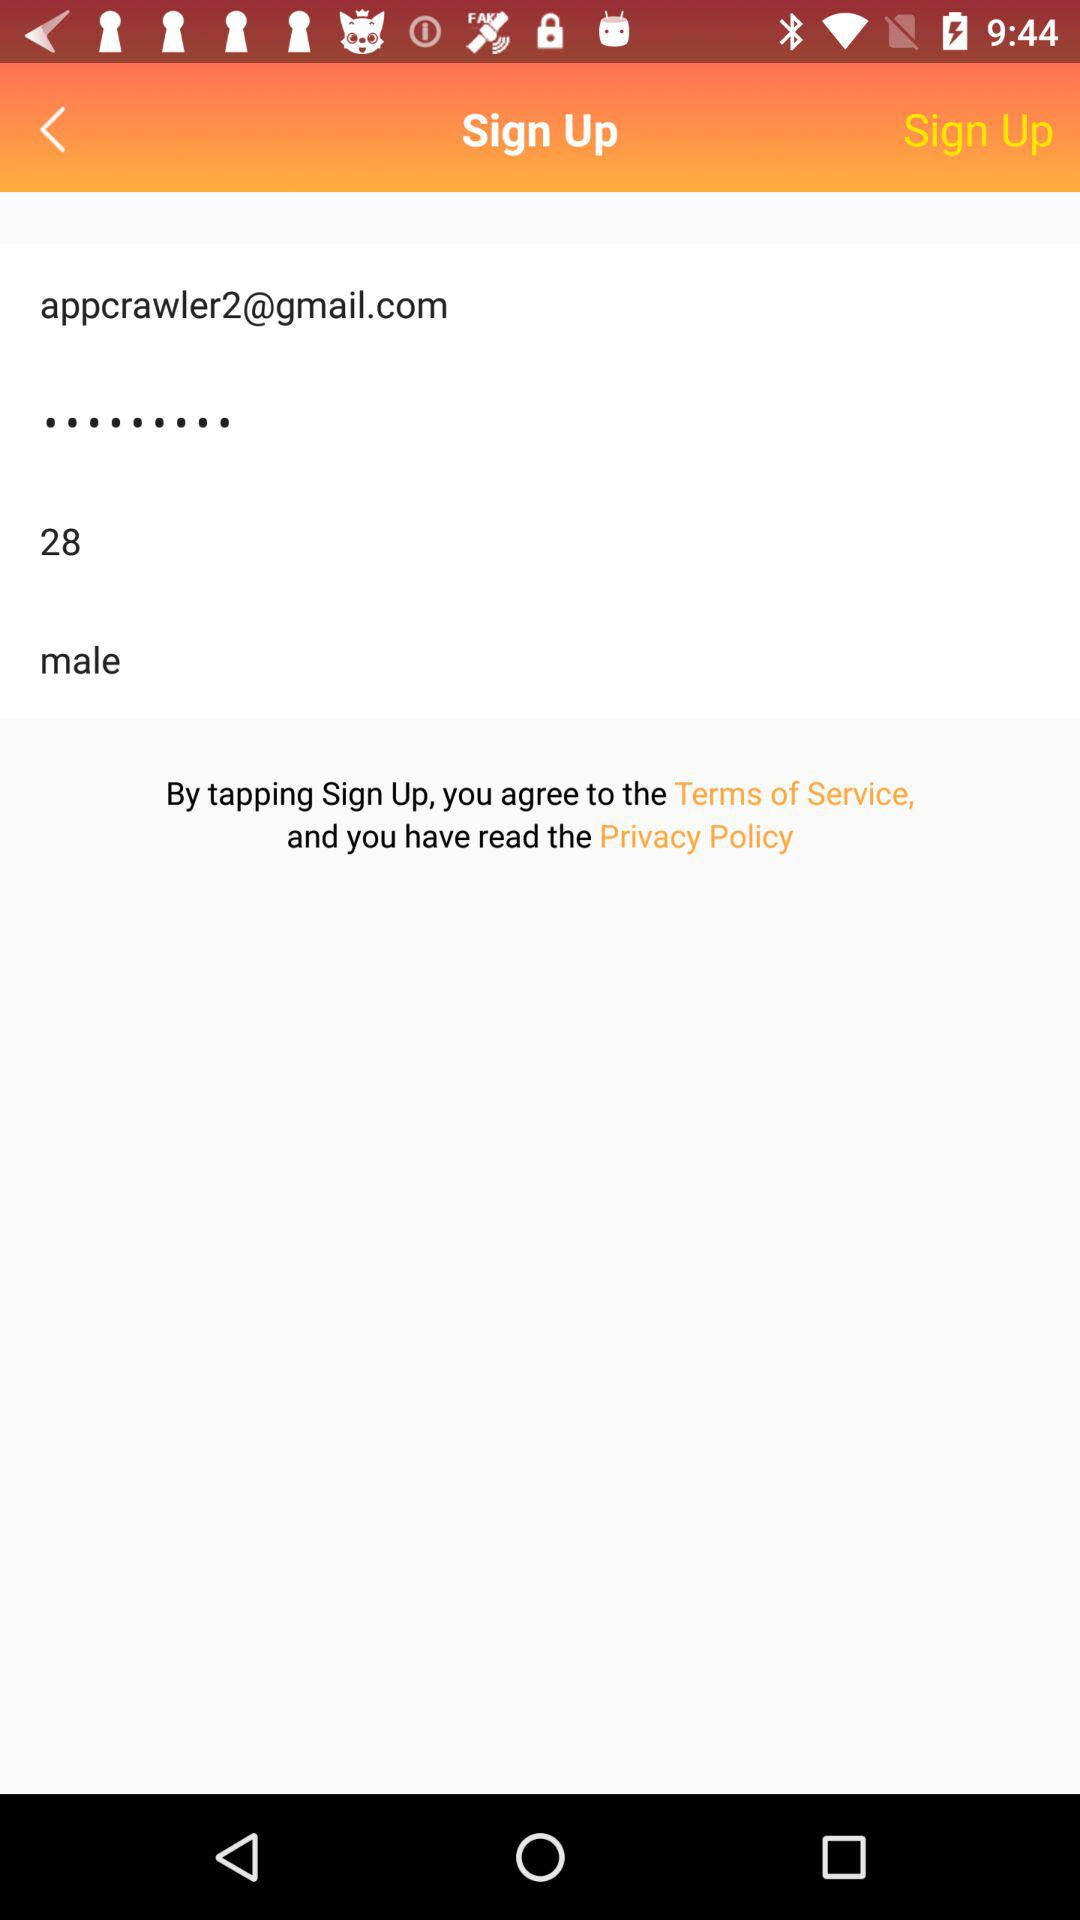What is the email address? The email address is appcrawler2@gmail.com. 